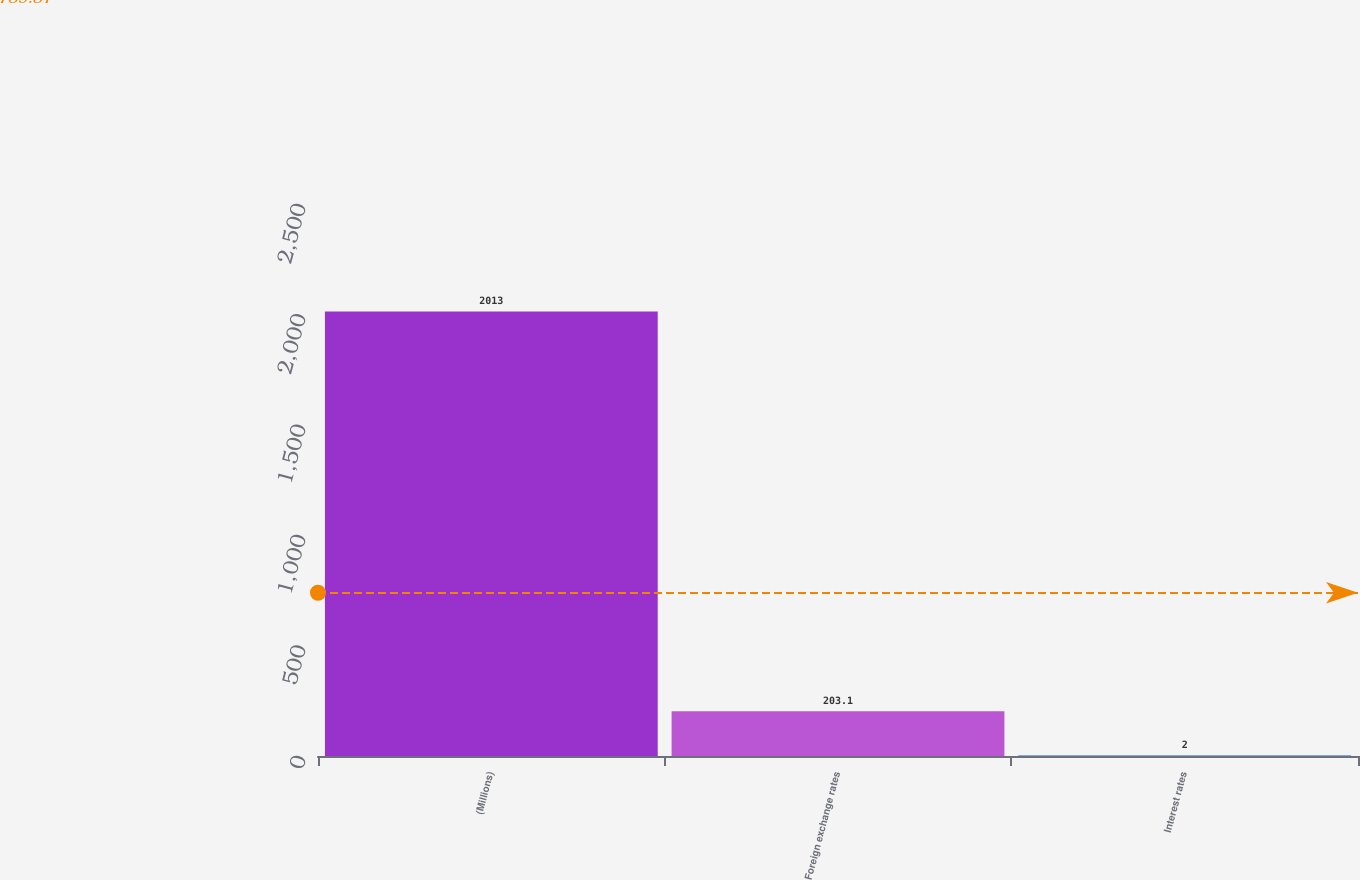Convert chart to OTSL. <chart><loc_0><loc_0><loc_500><loc_500><bar_chart><fcel>(Millions)<fcel>Foreign exchange rates<fcel>Interest rates<nl><fcel>2013<fcel>203.1<fcel>2<nl></chart> 